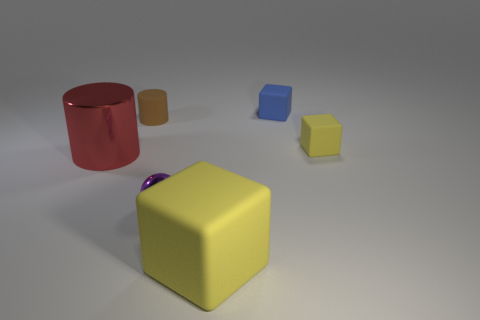Add 4 big gray rubber blocks. How many objects exist? 10 Subtract all cylinders. How many objects are left? 4 Subtract all small red rubber blocks. Subtract all big metallic cylinders. How many objects are left? 5 Add 3 tiny cylinders. How many tiny cylinders are left? 4 Add 1 blue objects. How many blue objects exist? 2 Subtract 0 green cylinders. How many objects are left? 6 